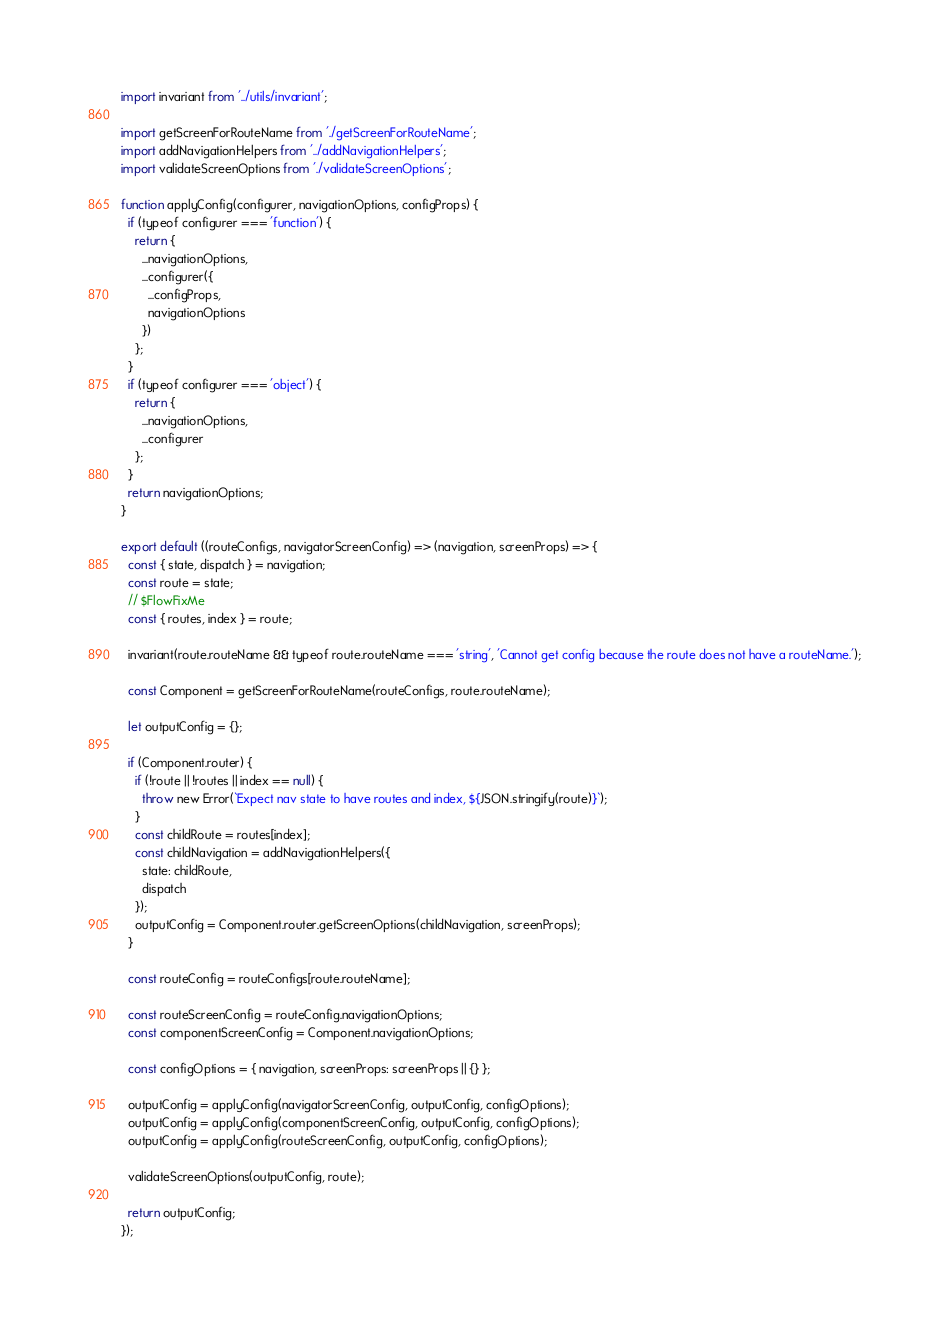<code> <loc_0><loc_0><loc_500><loc_500><_JavaScript_>import invariant from '../utils/invariant';

import getScreenForRouteName from './getScreenForRouteName';
import addNavigationHelpers from '../addNavigationHelpers';
import validateScreenOptions from './validateScreenOptions';

function applyConfig(configurer, navigationOptions, configProps) {
  if (typeof configurer === 'function') {
    return {
      ...navigationOptions,
      ...configurer({
        ...configProps,
        navigationOptions
      })
    };
  }
  if (typeof configurer === 'object') {
    return {
      ...navigationOptions,
      ...configurer
    };
  }
  return navigationOptions;
}

export default ((routeConfigs, navigatorScreenConfig) => (navigation, screenProps) => {
  const { state, dispatch } = navigation;
  const route = state;
  // $FlowFixMe
  const { routes, index } = route;

  invariant(route.routeName && typeof route.routeName === 'string', 'Cannot get config because the route does not have a routeName.');

  const Component = getScreenForRouteName(routeConfigs, route.routeName);

  let outputConfig = {};

  if (Component.router) {
    if (!route || !routes || index == null) {
      throw new Error(`Expect nav state to have routes and index, ${JSON.stringify(route)}`);
    }
    const childRoute = routes[index];
    const childNavigation = addNavigationHelpers({
      state: childRoute,
      dispatch
    });
    outputConfig = Component.router.getScreenOptions(childNavigation, screenProps);
  }

  const routeConfig = routeConfigs[route.routeName];

  const routeScreenConfig = routeConfig.navigationOptions;
  const componentScreenConfig = Component.navigationOptions;

  const configOptions = { navigation, screenProps: screenProps || {} };

  outputConfig = applyConfig(navigatorScreenConfig, outputConfig, configOptions);
  outputConfig = applyConfig(componentScreenConfig, outputConfig, configOptions);
  outputConfig = applyConfig(routeScreenConfig, outputConfig, configOptions);

  validateScreenOptions(outputConfig, route);

  return outputConfig;
});</code> 